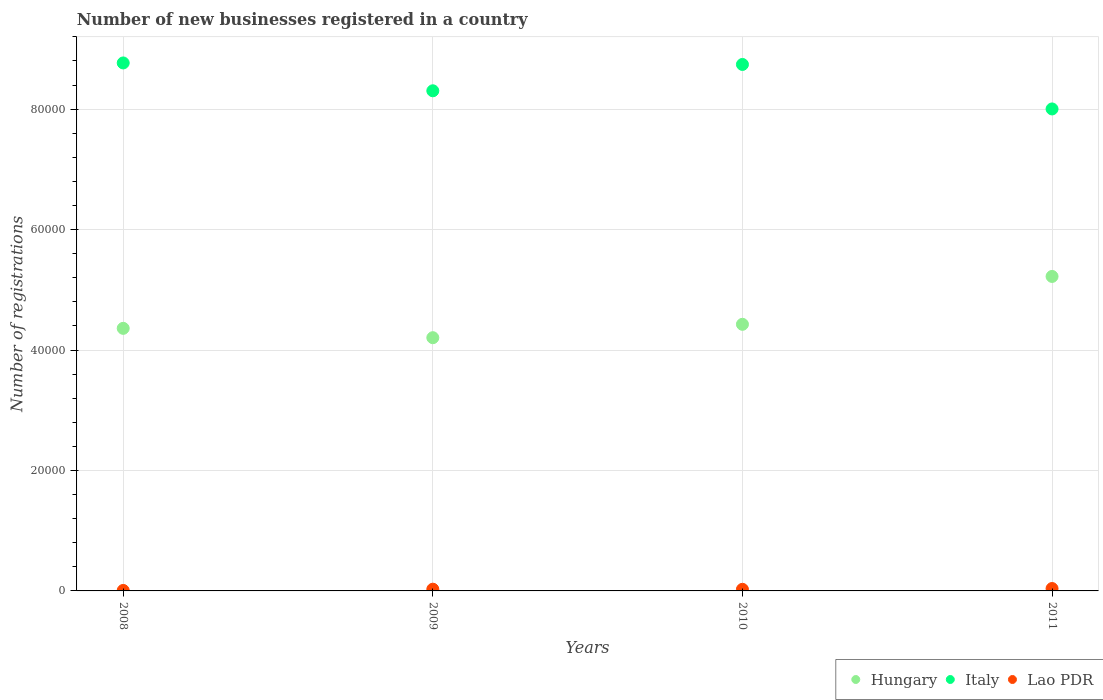How many different coloured dotlines are there?
Your response must be concise. 3. What is the number of new businesses registered in Italy in 2009?
Give a very brief answer. 8.30e+04. Across all years, what is the maximum number of new businesses registered in Hungary?
Your response must be concise. 5.22e+04. Across all years, what is the minimum number of new businesses registered in Italy?
Give a very brief answer. 8.00e+04. In which year was the number of new businesses registered in Lao PDR minimum?
Give a very brief answer. 2008. What is the total number of new businesses registered in Italy in the graph?
Your answer should be very brief. 3.38e+05. What is the difference between the number of new businesses registered in Italy in 2009 and that in 2011?
Keep it short and to the point. 3014. What is the difference between the number of new businesses registered in Lao PDR in 2011 and the number of new businesses registered in Italy in 2010?
Ensure brevity in your answer.  -8.70e+04. What is the average number of new businesses registered in Hungary per year?
Make the answer very short. 4.55e+04. In the year 2010, what is the difference between the number of new businesses registered in Hungary and number of new businesses registered in Lao PDR?
Your answer should be compact. 4.40e+04. In how many years, is the number of new businesses registered in Italy greater than 64000?
Offer a very short reply. 4. What is the ratio of the number of new businesses registered in Italy in 2009 to that in 2011?
Offer a very short reply. 1.04. Is the difference between the number of new businesses registered in Hungary in 2009 and 2010 greater than the difference between the number of new businesses registered in Lao PDR in 2009 and 2010?
Provide a short and direct response. No. What is the difference between the highest and the second highest number of new businesses registered in Italy?
Offer a terse response. 250. What is the difference between the highest and the lowest number of new businesses registered in Italy?
Your answer should be very brief. 7637. Is the sum of the number of new businesses registered in Hungary in 2009 and 2011 greater than the maximum number of new businesses registered in Lao PDR across all years?
Offer a very short reply. Yes. Does the number of new businesses registered in Hungary monotonically increase over the years?
Offer a terse response. No. Is the number of new businesses registered in Hungary strictly less than the number of new businesses registered in Italy over the years?
Your answer should be very brief. Yes. Does the graph contain any zero values?
Keep it short and to the point. No. What is the title of the graph?
Your response must be concise. Number of new businesses registered in a country. What is the label or title of the X-axis?
Make the answer very short. Years. What is the label or title of the Y-axis?
Provide a succinct answer. Number of registrations. What is the Number of registrations of Hungary in 2008?
Your response must be concise. 4.36e+04. What is the Number of registrations in Italy in 2008?
Your answer should be very brief. 8.77e+04. What is the Number of registrations in Hungary in 2009?
Ensure brevity in your answer.  4.20e+04. What is the Number of registrations of Italy in 2009?
Offer a very short reply. 8.30e+04. What is the Number of registrations in Lao PDR in 2009?
Your answer should be compact. 286. What is the Number of registrations in Hungary in 2010?
Your answer should be compact. 4.43e+04. What is the Number of registrations in Italy in 2010?
Provide a short and direct response. 8.74e+04. What is the Number of registrations of Lao PDR in 2010?
Offer a very short reply. 265. What is the Number of registrations in Hungary in 2011?
Keep it short and to the point. 5.22e+04. What is the Number of registrations of Italy in 2011?
Your answer should be compact. 8.00e+04. What is the Number of registrations of Lao PDR in 2011?
Keep it short and to the point. 398. Across all years, what is the maximum Number of registrations in Hungary?
Your answer should be very brief. 5.22e+04. Across all years, what is the maximum Number of registrations in Italy?
Provide a short and direct response. 8.77e+04. Across all years, what is the maximum Number of registrations in Lao PDR?
Your response must be concise. 398. Across all years, what is the minimum Number of registrations in Hungary?
Your response must be concise. 4.20e+04. Across all years, what is the minimum Number of registrations in Italy?
Provide a short and direct response. 8.00e+04. What is the total Number of registrations of Hungary in the graph?
Make the answer very short. 1.82e+05. What is the total Number of registrations in Italy in the graph?
Your answer should be very brief. 3.38e+05. What is the total Number of registrations in Lao PDR in the graph?
Your response must be concise. 1029. What is the difference between the Number of registrations of Hungary in 2008 and that in 2009?
Provide a succinct answer. 1552. What is the difference between the Number of registrations in Italy in 2008 and that in 2009?
Provide a short and direct response. 4623. What is the difference between the Number of registrations in Lao PDR in 2008 and that in 2009?
Offer a very short reply. -206. What is the difference between the Number of registrations in Hungary in 2008 and that in 2010?
Your response must be concise. -671. What is the difference between the Number of registrations of Italy in 2008 and that in 2010?
Your answer should be very brief. 250. What is the difference between the Number of registrations in Lao PDR in 2008 and that in 2010?
Your answer should be very brief. -185. What is the difference between the Number of registrations in Hungary in 2008 and that in 2011?
Your response must be concise. -8619. What is the difference between the Number of registrations of Italy in 2008 and that in 2011?
Your response must be concise. 7637. What is the difference between the Number of registrations of Lao PDR in 2008 and that in 2011?
Keep it short and to the point. -318. What is the difference between the Number of registrations in Hungary in 2009 and that in 2010?
Your response must be concise. -2223. What is the difference between the Number of registrations of Italy in 2009 and that in 2010?
Give a very brief answer. -4373. What is the difference between the Number of registrations in Hungary in 2009 and that in 2011?
Your answer should be very brief. -1.02e+04. What is the difference between the Number of registrations of Italy in 2009 and that in 2011?
Keep it short and to the point. 3014. What is the difference between the Number of registrations of Lao PDR in 2009 and that in 2011?
Make the answer very short. -112. What is the difference between the Number of registrations in Hungary in 2010 and that in 2011?
Keep it short and to the point. -7948. What is the difference between the Number of registrations in Italy in 2010 and that in 2011?
Keep it short and to the point. 7387. What is the difference between the Number of registrations in Lao PDR in 2010 and that in 2011?
Offer a very short reply. -133. What is the difference between the Number of registrations of Hungary in 2008 and the Number of registrations of Italy in 2009?
Offer a terse response. -3.94e+04. What is the difference between the Number of registrations in Hungary in 2008 and the Number of registrations in Lao PDR in 2009?
Keep it short and to the point. 4.33e+04. What is the difference between the Number of registrations of Italy in 2008 and the Number of registrations of Lao PDR in 2009?
Your response must be concise. 8.74e+04. What is the difference between the Number of registrations of Hungary in 2008 and the Number of registrations of Italy in 2010?
Provide a succinct answer. -4.38e+04. What is the difference between the Number of registrations of Hungary in 2008 and the Number of registrations of Lao PDR in 2010?
Offer a very short reply. 4.33e+04. What is the difference between the Number of registrations in Italy in 2008 and the Number of registrations in Lao PDR in 2010?
Offer a very short reply. 8.74e+04. What is the difference between the Number of registrations of Hungary in 2008 and the Number of registrations of Italy in 2011?
Keep it short and to the point. -3.64e+04. What is the difference between the Number of registrations of Hungary in 2008 and the Number of registrations of Lao PDR in 2011?
Keep it short and to the point. 4.32e+04. What is the difference between the Number of registrations in Italy in 2008 and the Number of registrations in Lao PDR in 2011?
Offer a terse response. 8.73e+04. What is the difference between the Number of registrations in Hungary in 2009 and the Number of registrations in Italy in 2010?
Your answer should be very brief. -4.54e+04. What is the difference between the Number of registrations in Hungary in 2009 and the Number of registrations in Lao PDR in 2010?
Offer a terse response. 4.18e+04. What is the difference between the Number of registrations in Italy in 2009 and the Number of registrations in Lao PDR in 2010?
Make the answer very short. 8.28e+04. What is the difference between the Number of registrations of Hungary in 2009 and the Number of registrations of Italy in 2011?
Keep it short and to the point. -3.80e+04. What is the difference between the Number of registrations of Hungary in 2009 and the Number of registrations of Lao PDR in 2011?
Offer a very short reply. 4.16e+04. What is the difference between the Number of registrations in Italy in 2009 and the Number of registrations in Lao PDR in 2011?
Your answer should be compact. 8.26e+04. What is the difference between the Number of registrations in Hungary in 2010 and the Number of registrations in Italy in 2011?
Provide a succinct answer. -3.58e+04. What is the difference between the Number of registrations of Hungary in 2010 and the Number of registrations of Lao PDR in 2011?
Offer a terse response. 4.39e+04. What is the difference between the Number of registrations of Italy in 2010 and the Number of registrations of Lao PDR in 2011?
Give a very brief answer. 8.70e+04. What is the average Number of registrations of Hungary per year?
Your answer should be compact. 4.55e+04. What is the average Number of registrations in Italy per year?
Offer a very short reply. 8.45e+04. What is the average Number of registrations of Lao PDR per year?
Ensure brevity in your answer.  257.25. In the year 2008, what is the difference between the Number of registrations of Hungary and Number of registrations of Italy?
Your answer should be compact. -4.41e+04. In the year 2008, what is the difference between the Number of registrations of Hungary and Number of registrations of Lao PDR?
Provide a succinct answer. 4.35e+04. In the year 2008, what is the difference between the Number of registrations in Italy and Number of registrations in Lao PDR?
Keep it short and to the point. 8.76e+04. In the year 2009, what is the difference between the Number of registrations of Hungary and Number of registrations of Italy?
Give a very brief answer. -4.10e+04. In the year 2009, what is the difference between the Number of registrations of Hungary and Number of registrations of Lao PDR?
Your answer should be compact. 4.18e+04. In the year 2009, what is the difference between the Number of registrations of Italy and Number of registrations of Lao PDR?
Your response must be concise. 8.28e+04. In the year 2010, what is the difference between the Number of registrations in Hungary and Number of registrations in Italy?
Give a very brief answer. -4.31e+04. In the year 2010, what is the difference between the Number of registrations of Hungary and Number of registrations of Lao PDR?
Provide a succinct answer. 4.40e+04. In the year 2010, what is the difference between the Number of registrations in Italy and Number of registrations in Lao PDR?
Keep it short and to the point. 8.72e+04. In the year 2011, what is the difference between the Number of registrations of Hungary and Number of registrations of Italy?
Keep it short and to the point. -2.78e+04. In the year 2011, what is the difference between the Number of registrations of Hungary and Number of registrations of Lao PDR?
Your answer should be very brief. 5.18e+04. In the year 2011, what is the difference between the Number of registrations of Italy and Number of registrations of Lao PDR?
Provide a short and direct response. 7.96e+04. What is the ratio of the Number of registrations of Hungary in 2008 to that in 2009?
Make the answer very short. 1.04. What is the ratio of the Number of registrations in Italy in 2008 to that in 2009?
Your response must be concise. 1.06. What is the ratio of the Number of registrations of Lao PDR in 2008 to that in 2009?
Keep it short and to the point. 0.28. What is the ratio of the Number of registrations in Lao PDR in 2008 to that in 2010?
Offer a very short reply. 0.3. What is the ratio of the Number of registrations in Hungary in 2008 to that in 2011?
Provide a succinct answer. 0.83. What is the ratio of the Number of registrations in Italy in 2008 to that in 2011?
Ensure brevity in your answer.  1.1. What is the ratio of the Number of registrations in Lao PDR in 2008 to that in 2011?
Your answer should be compact. 0.2. What is the ratio of the Number of registrations in Hungary in 2009 to that in 2010?
Your response must be concise. 0.95. What is the ratio of the Number of registrations in Italy in 2009 to that in 2010?
Offer a terse response. 0.95. What is the ratio of the Number of registrations of Lao PDR in 2009 to that in 2010?
Provide a short and direct response. 1.08. What is the ratio of the Number of registrations in Hungary in 2009 to that in 2011?
Provide a succinct answer. 0.81. What is the ratio of the Number of registrations in Italy in 2009 to that in 2011?
Your answer should be compact. 1.04. What is the ratio of the Number of registrations in Lao PDR in 2009 to that in 2011?
Give a very brief answer. 0.72. What is the ratio of the Number of registrations in Hungary in 2010 to that in 2011?
Your answer should be compact. 0.85. What is the ratio of the Number of registrations of Italy in 2010 to that in 2011?
Your response must be concise. 1.09. What is the ratio of the Number of registrations in Lao PDR in 2010 to that in 2011?
Make the answer very short. 0.67. What is the difference between the highest and the second highest Number of registrations of Hungary?
Your answer should be very brief. 7948. What is the difference between the highest and the second highest Number of registrations in Italy?
Make the answer very short. 250. What is the difference between the highest and the second highest Number of registrations in Lao PDR?
Your answer should be compact. 112. What is the difference between the highest and the lowest Number of registrations in Hungary?
Your answer should be very brief. 1.02e+04. What is the difference between the highest and the lowest Number of registrations of Italy?
Your answer should be compact. 7637. What is the difference between the highest and the lowest Number of registrations of Lao PDR?
Ensure brevity in your answer.  318. 